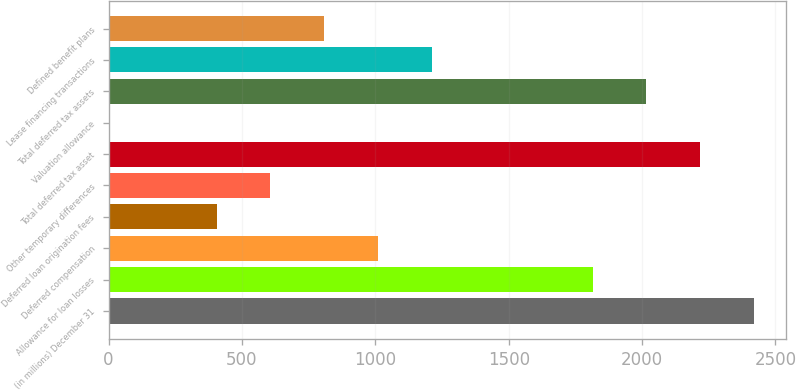Convert chart to OTSL. <chart><loc_0><loc_0><loc_500><loc_500><bar_chart><fcel>(in millions) December 31<fcel>Allowance for loan losses<fcel>Deferred compensation<fcel>Deferred loan origination fees<fcel>Other temporary differences<fcel>Total deferred tax asset<fcel>Valuation allowance<fcel>Total deferred tax assets<fcel>Lease financing transactions<fcel>Defined benefit plans<nl><fcel>2418.6<fcel>1814.7<fcel>1009.5<fcel>405.6<fcel>606.9<fcel>2217.3<fcel>3<fcel>2016<fcel>1210.8<fcel>808.2<nl></chart> 